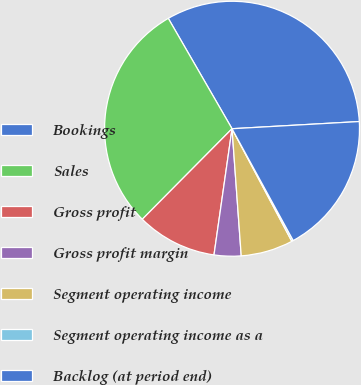<chart> <loc_0><loc_0><loc_500><loc_500><pie_chart><fcel>Bookings<fcel>Sales<fcel>Gross profit<fcel>Gross profit margin<fcel>Segment operating income<fcel>Segment operating income as a<fcel>Backlog (at period end)<nl><fcel>32.44%<fcel>29.23%<fcel>10.17%<fcel>3.41%<fcel>6.62%<fcel>0.2%<fcel>17.93%<nl></chart> 